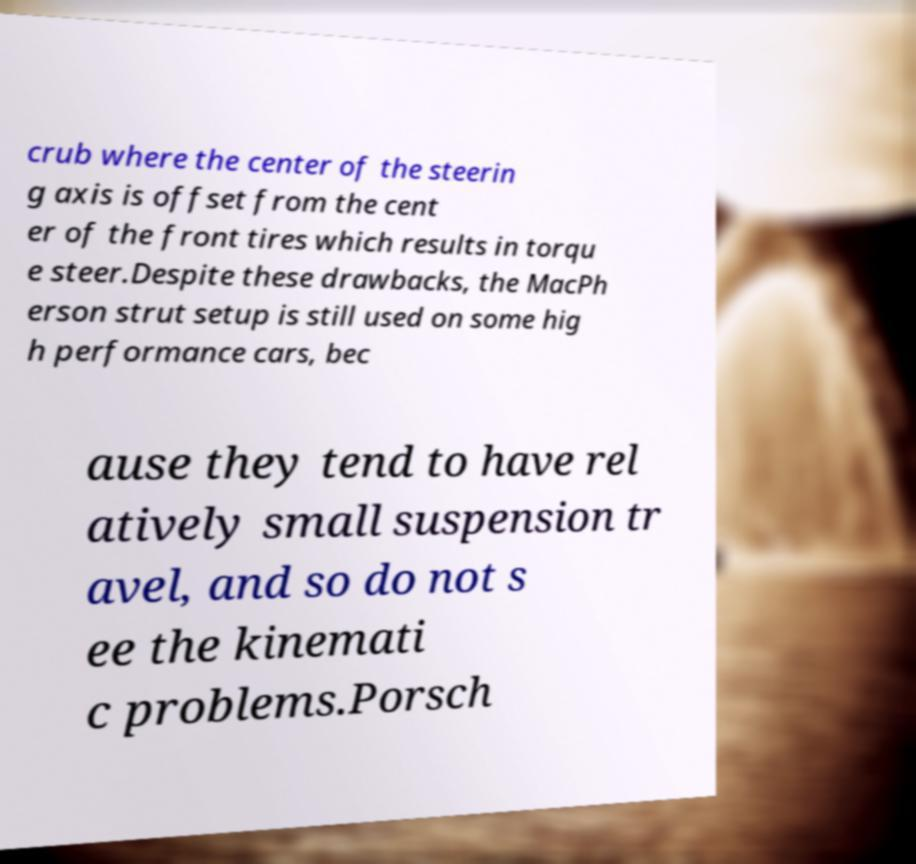What messages or text are displayed in this image? I need them in a readable, typed format. crub where the center of the steerin g axis is offset from the cent er of the front tires which results in torqu e steer.Despite these drawbacks, the MacPh erson strut setup is still used on some hig h performance cars, bec ause they tend to have rel atively small suspension tr avel, and so do not s ee the kinemati c problems.Porsch 